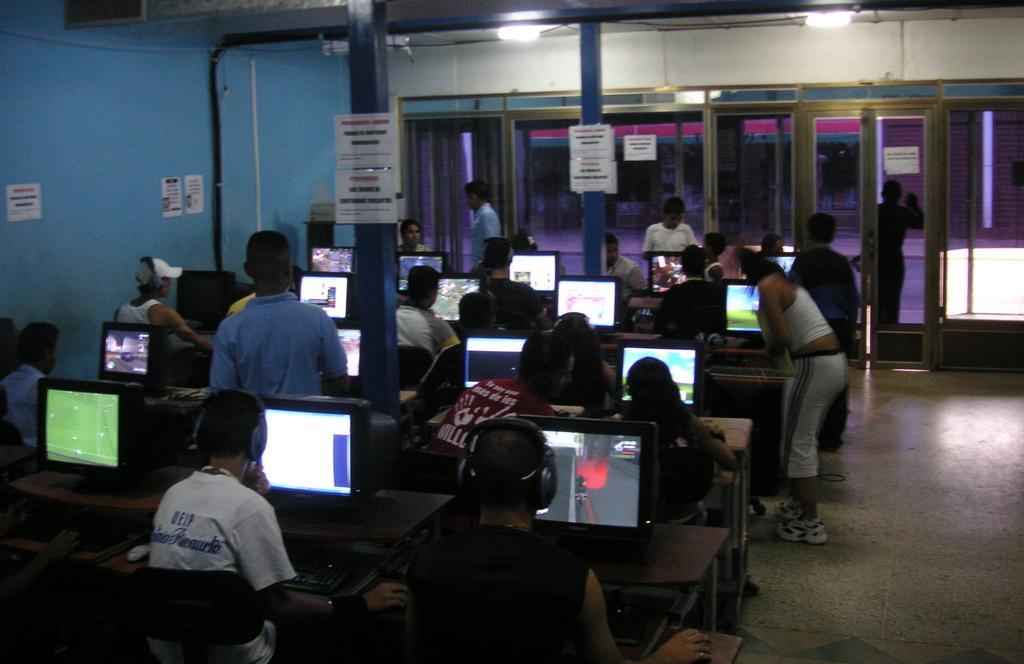Could you give a brief overview of what you see in this image? On the left side, there are persons. Some of them are sitting on the chairs in front of the tables, on which there are monitors arranged and there are posters attached to the blue color wall and blue color pillars. In the background, there are glass windows and doors, on which there are posters. 